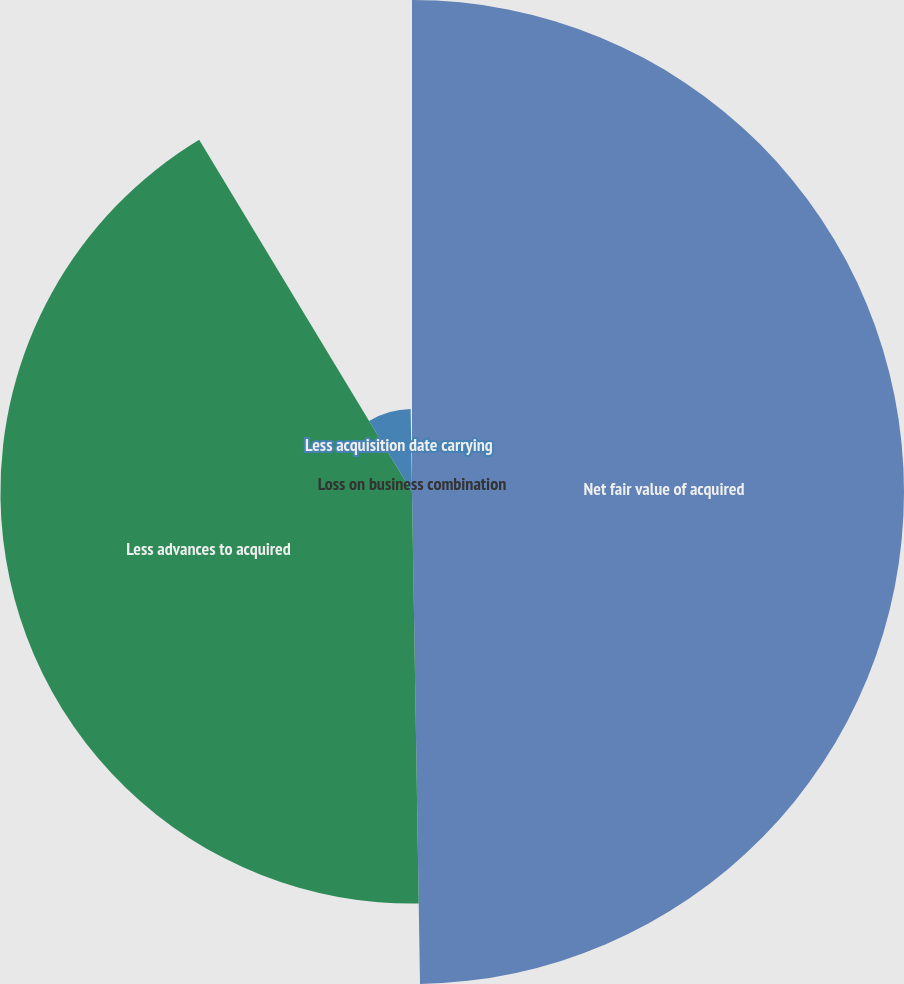Convert chart to OTSL. <chart><loc_0><loc_0><loc_500><loc_500><pie_chart><fcel>Net fair value of acquired<fcel>Less advances to acquired<fcel>Less acquisition date carrying<fcel>Loss on business combination<nl><fcel>49.74%<fcel>41.61%<fcel>8.39%<fcel>0.26%<nl></chart> 